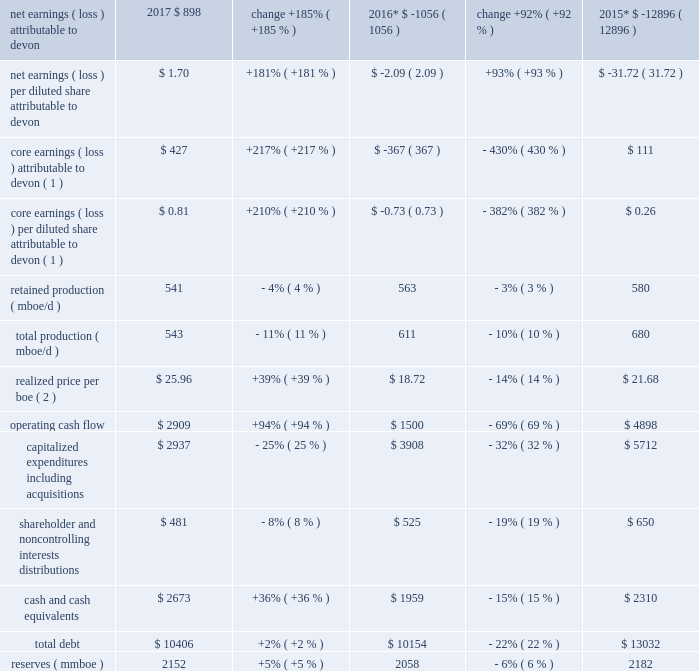Item 7 .
Management 2019s discussion and analysis of financial condition and results of operations introduction the following discussion and analysis presents management 2019s perspective of our business , financial condition and overall performance .
This information is intended to provide investors with an understanding of our past performance , current financial condition and outlook for the future and should be read in conjunction with 201citem 8 .
Financial statements and supplementary data 201d of this report .
Overview of 2017 results during 2017 , we generated solid operating results with our strategy of operating in north america 2019s best resource plays , delivering superior execution , continuing disciplined capital allocation and maintaining a high degree of financial strength .
Led by our development in the stack and delaware basin , we continued to improve our 90-day initial production rates .
With investments in proprietary data tools , predictive analytics and artificial intelligence , we are delivering industry-leading , initial-rate well productivity performance and improving the performance of our established wells .
Compared to 2016 , commodity prices increased significantly and were the primary driver for improvements in devon 2019s earnings and cash flow during 2017 .
We exited 2017 with liquidity comprised of $ 2.7 billion of cash and $ 2.9 billion of available credit under our senior credit facility .
We have no significant debt maturities until 2021 .
We further enhanced our financial strength by completing approximately $ 415 million of our announced $ 1 billion asset divestiture program in 2017 .
We anticipate closing the remaining divestitures in 2018 .
In 2018 and beyond , we have the financial capacity to further accelerate investment across our best-in-class u.s .
Resource plays .
We are increasing drilling activity and will continue to shift our production mix to high-margin products .
We will continue our premier technical work to drive capital allocation and efficiency and industry- leading well productivity results .
We will continue to maximize the value of our base production by sustaining the operational efficiencies we have achieved .
Finally , we will continue to manage activity levels within our cash flows .
We expect this disciplined approach will position us to deliver capital-efficient , cash-flow expansion over the next two years .
Key measures of our financial performance in 2017 are summarized in the table .
Increased commodity prices as well as continued focus on our production expenses improved our 2017 financial performance as compared to 2016 , as seen in the table below .
More details for these metrics are found within the 201cresults of operations 2013 2017 vs .
2016 201d , below. .

What is the ratio of operating cash flow to total debt in 2016? 
Computations: (10154 / 1500)
Answer: 6.76933. 